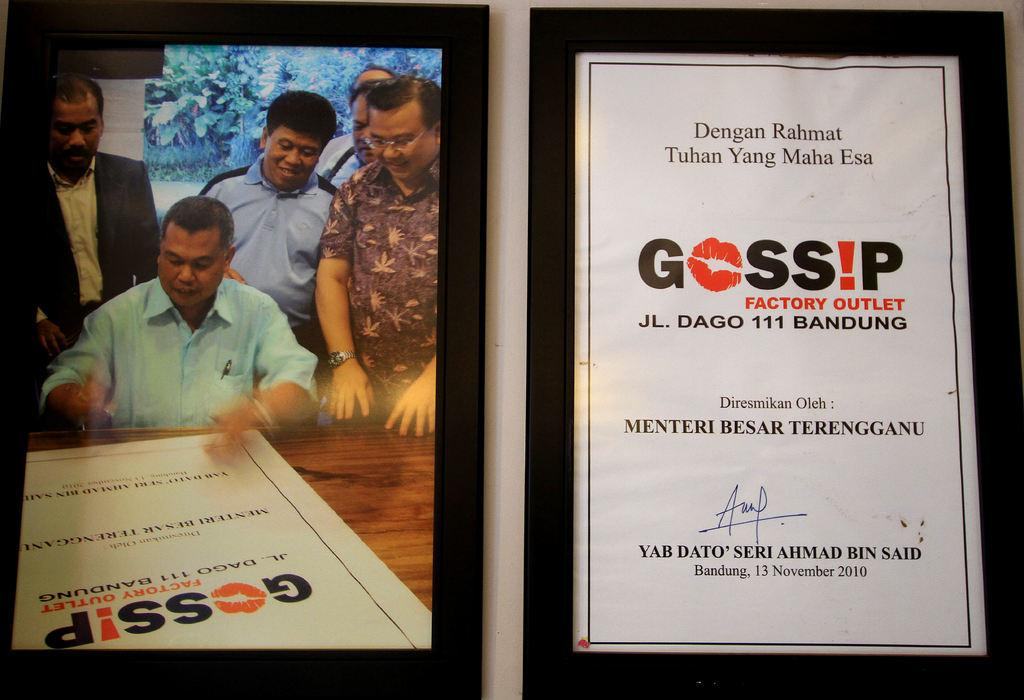<image>
Relay a brief, clear account of the picture shown. A signed document from 13 November 2010 from the Gossip Factory Outlet. 